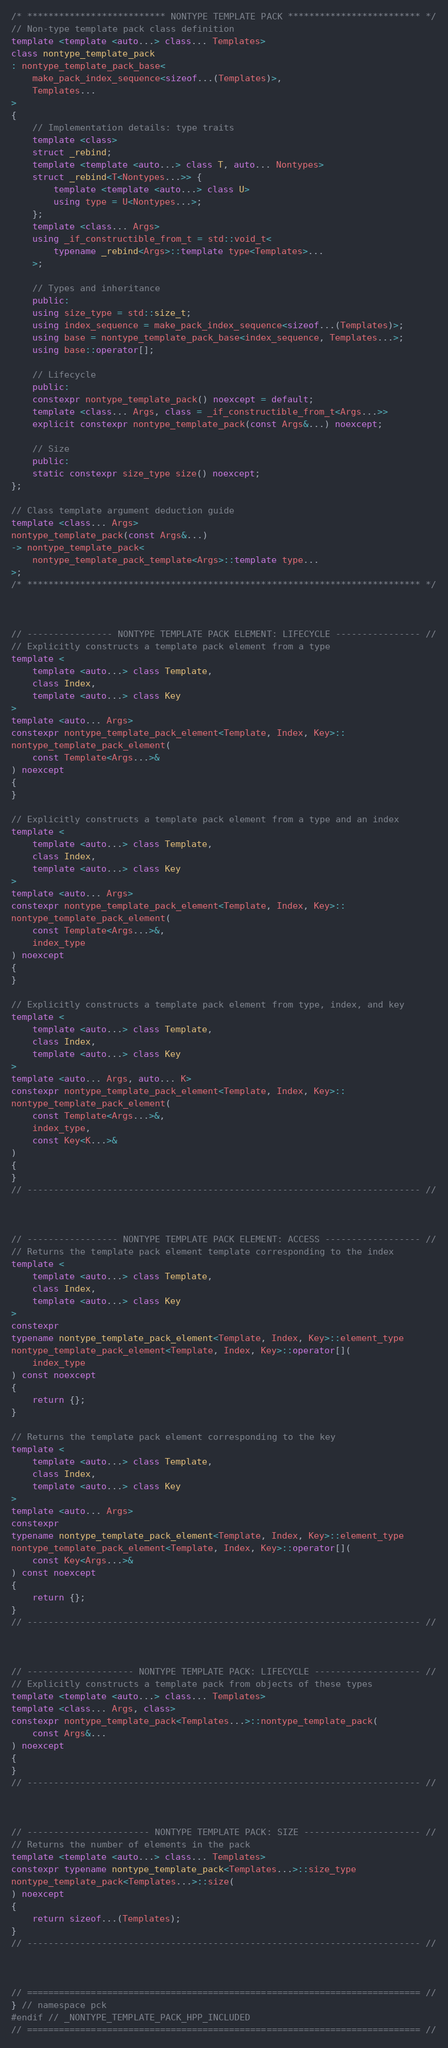Convert code to text. <code><loc_0><loc_0><loc_500><loc_500><_C++_>

/* ************************** NONTYPE TEMPLATE PACK ************************* */
// Non-type template pack class definition
template <template <auto...> class... Templates>
class nontype_template_pack
: nontype_template_pack_base<
    make_pack_index_sequence<sizeof...(Templates)>,
    Templates...
>
{
    // Implementation details: type traits
    template <class>
    struct _rebind;
    template <template <auto...> class T, auto... Nontypes>
    struct _rebind<T<Nontypes...>> {
        template <template <auto...> class U>
        using type = U<Nontypes...>;
    };
    template <class... Args>
    using _if_constructible_from_t = std::void_t<
        typename _rebind<Args>::template type<Templates>...
    >;
    
    // Types and inheritance
    public:
    using size_type = std::size_t;
    using index_sequence = make_pack_index_sequence<sizeof...(Templates)>;
    using base = nontype_template_pack_base<index_sequence, Templates...>;
    using base::operator[];

    // Lifecycle
    public:
    constexpr nontype_template_pack() noexcept = default;
    template <class... Args, class = _if_constructible_from_t<Args...>>
    explicit constexpr nontype_template_pack(const Args&...) noexcept;

    // Size
    public:
    static constexpr size_type size() noexcept;
};

// Class template argument deduction guide
template <class... Args>
nontype_template_pack(const Args&...)
-> nontype_template_pack<
    nontype_template_pack_template<Args>::template type...
>;
/* ************************************************************************** */



// ---------------- NONTYPE TEMPLATE PACK ELEMENT: LIFECYCLE ---------------- //
// Explicitly constructs a template pack element from a type
template <
    template <auto...> class Template,
    class Index,
    template <auto...> class Key
>
template <auto... Args>
constexpr nontype_template_pack_element<Template, Index, Key>::
nontype_template_pack_element(
    const Template<Args...>&
) noexcept
{
}

// Explicitly constructs a template pack element from a type and an index
template <
    template <auto...> class Template,
    class Index,
    template <auto...> class Key
>
template <auto... Args>
constexpr nontype_template_pack_element<Template, Index, Key>::
nontype_template_pack_element(
    const Template<Args...>&,
    index_type
) noexcept
{
}

// Explicitly constructs a template pack element from type, index, and key
template <
    template <auto...> class Template,
    class Index,
    template <auto...> class Key
>
template <auto... Args, auto... K>
constexpr nontype_template_pack_element<Template, Index, Key>::
nontype_template_pack_element(
    const Template<Args...>&,
    index_type,
    const Key<K...>&
)
{
}
// -------------------------------------------------------------------------- //



// ----------------- NONTYPE TEMPLATE PACK ELEMENT: ACCESS ------------------ //
// Returns the template pack element template corresponding to the index
template <
    template <auto...> class Template,
    class Index,
    template <auto...> class Key
>
constexpr
typename nontype_template_pack_element<Template, Index, Key>::element_type
nontype_template_pack_element<Template, Index, Key>::operator[](
    index_type
) const noexcept
{
    return {};
}

// Returns the template pack element corresponding to the key
template <
    template <auto...> class Template,
    class Index,
    template <auto...> class Key
>
template <auto... Args>
constexpr
typename nontype_template_pack_element<Template, Index, Key>::element_type
nontype_template_pack_element<Template, Index, Key>::operator[](
    const Key<Args...>&
) const noexcept
{
    return {};
}
// -------------------------------------------------------------------------- //



// -------------------- NONTYPE TEMPLATE PACK: LIFECYCLE -------------------- //
// Explicitly constructs a template pack from objects of these types
template <template <auto...> class... Templates>
template <class... Args, class>
constexpr nontype_template_pack<Templates...>::nontype_template_pack(
    const Args&...
) noexcept
{
}
// -------------------------------------------------------------------------- //



// ----------------------- NONTYPE TEMPLATE PACK: SIZE ---------------------- //
// Returns the number of elements in the pack
template <template <auto...> class... Templates>
constexpr typename nontype_template_pack<Templates...>::size_type
nontype_template_pack<Templates...>::size(
) noexcept
{
    return sizeof...(Templates);
}
// -------------------------------------------------------------------------- //



// ========================================================================== //
} // namespace pck
#endif // _NONTYPE_TEMPLATE_PACK_HPP_INCLUDED
// ========================================================================== //
</code> 